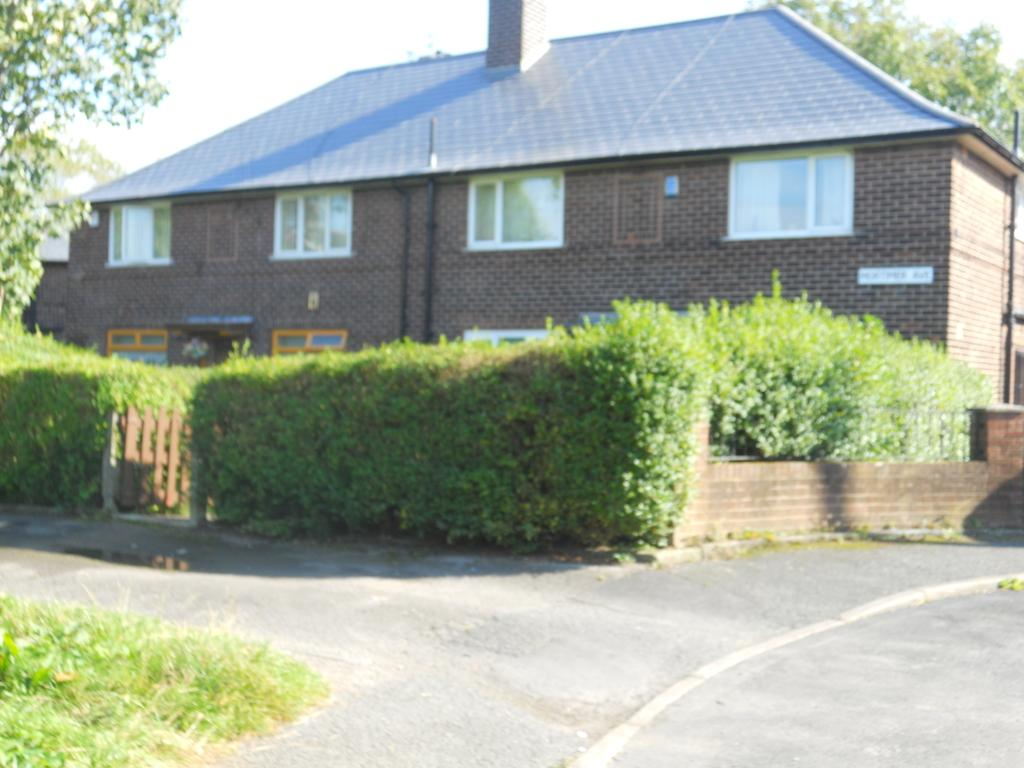What type of surface is visible at the bottom of the image? There is grass on the ground and road at the bottom of the image. What can be seen in the background of the image? There is a building, plants, a gate, windows, trees, and the sky visible in the background of the image. Where is the nest located in the image? There is no nest present in the image. What type of milk is being served in the image? There is no milk present in the image. 